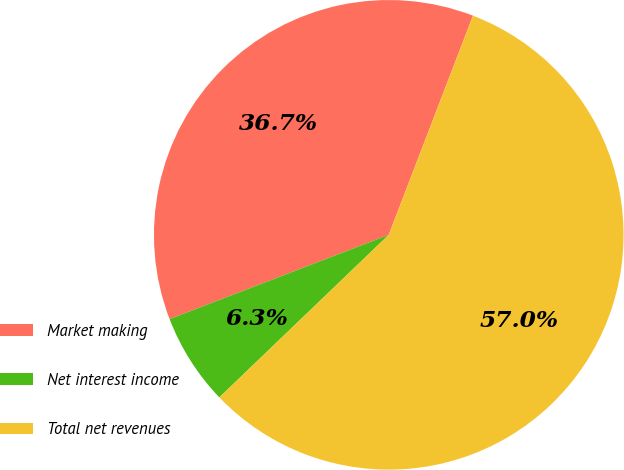Convert chart to OTSL. <chart><loc_0><loc_0><loc_500><loc_500><pie_chart><fcel>Market making<fcel>Net interest income<fcel>Total net revenues<nl><fcel>36.68%<fcel>6.33%<fcel>56.99%<nl></chart> 